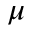Convert formula to latex. <formula><loc_0><loc_0><loc_500><loc_500>\mu</formula> 